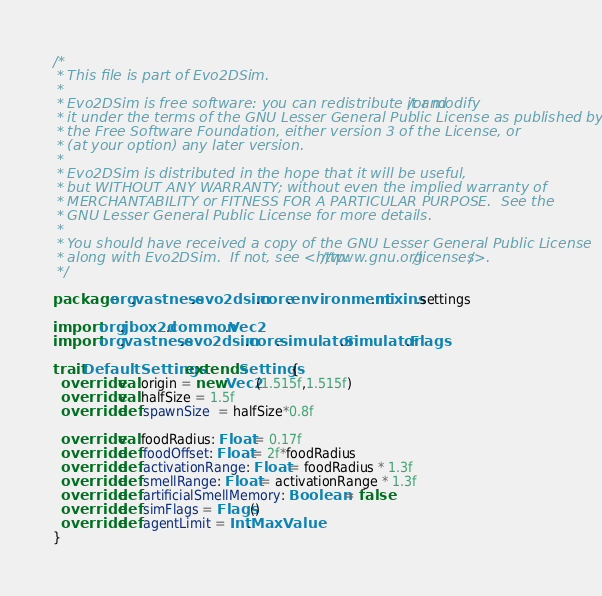<code> <loc_0><loc_0><loc_500><loc_500><_Scala_>/*
 * This file is part of Evo2DSim.
 *
 * Evo2DSim is free software: you can redistribute it and/or modify
 * it under the terms of the GNU Lesser General Public License as published by
 * the Free Software Foundation, either version 3 of the License, or
 * (at your option) any later version.
 *
 * Evo2DSim is distributed in the hope that it will be useful,
 * but WITHOUT ANY WARRANTY; without even the implied warranty of
 * MERCHANTABILITY or FITNESS FOR A PARTICULAR PURPOSE.  See the
 * GNU Lesser General Public License for more details.
 *
 * You should have received a copy of the GNU Lesser General Public License
 * along with Evo2DSim.  If not, see <http://www.gnu.org/licenses/>.
 */

package org.vastness.evo2dsim.core.environment.mixins.settings

import org.jbox2d.common.Vec2
import org.vastness.evo2dsim.core.simulator.Simulator.Flags

trait DefaultSettings extends Settings{
  override val origin = new Vec2(1.515f,1.515f)
  override val halfSize = 1.5f
  override def spawnSize  = halfSize*0.8f

  override val foodRadius: Float = 0.17f
  override def foodOffset: Float = 2f*foodRadius
  override def activationRange: Float = foodRadius * 1.3f
  override def smellRange: Float = activationRange * 1.3f
  override def artificialSmellMemory: Boolean = false
  override def simFlags = Flags()
  override def agentLimit = Int.MaxValue
}
</code> 